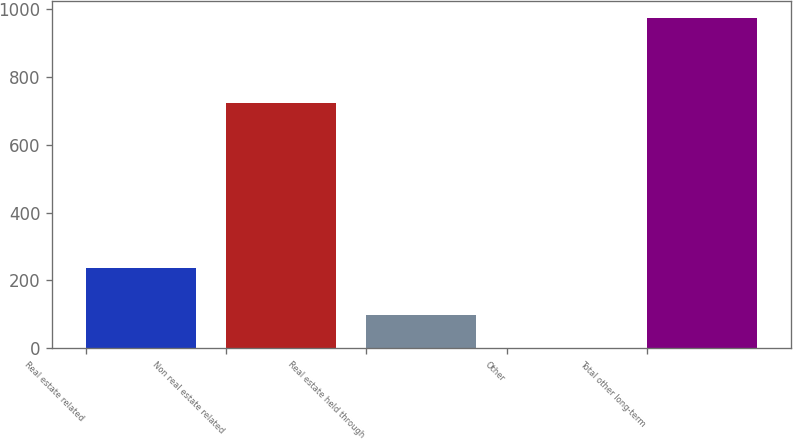<chart> <loc_0><loc_0><loc_500><loc_500><bar_chart><fcel>Real estate related<fcel>Non real estate related<fcel>Real estate held through<fcel>Other<fcel>Total other long-term<nl><fcel>237<fcel>724<fcel>98.2<fcel>1<fcel>973<nl></chart> 